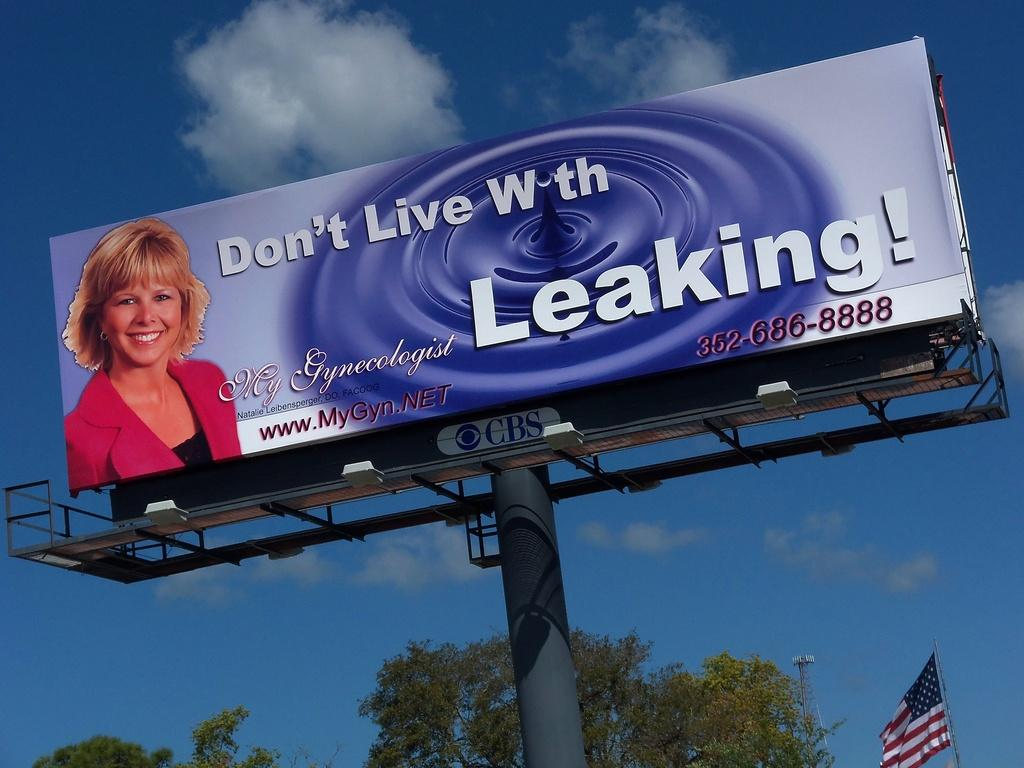<image>
Write a terse but informative summary of the picture. a billboard telling people to not live with the leak 